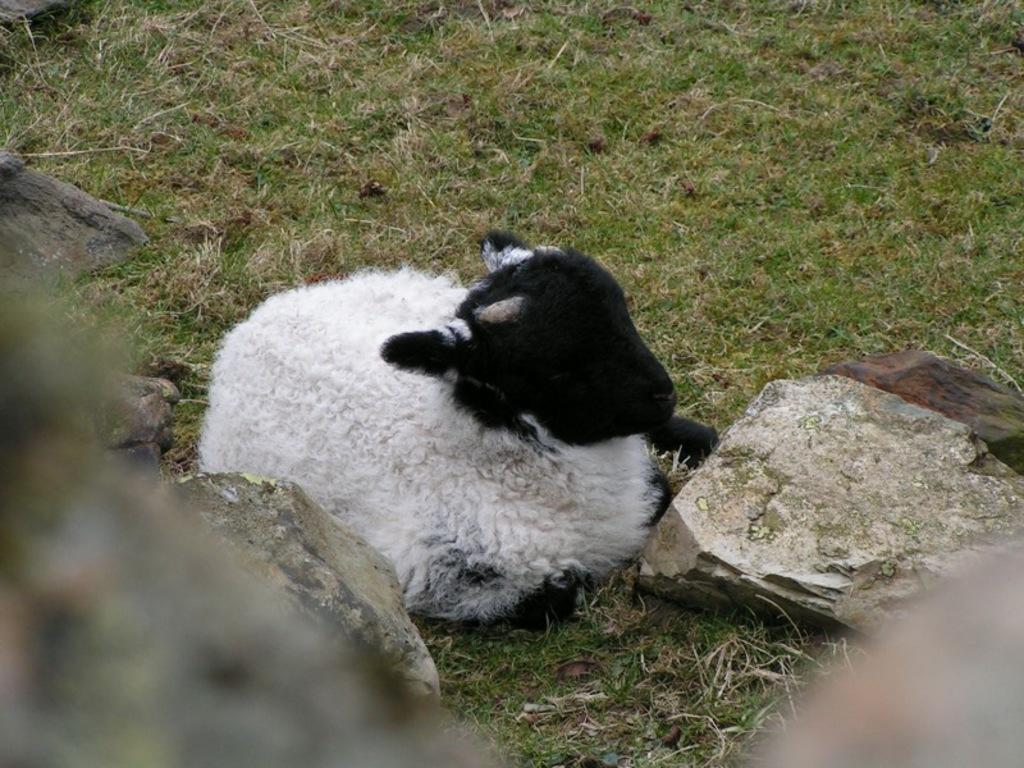What animal is present in the image? There is a sheep in the picture. What is the sheep doing in the image? The sheep is sitting on the grass. What type of vegetation can be seen in the image? There is grass visible in the image. What is located at the bottom of the image? There are stones at the bottom of the image. What type of tin can be seen hanging from the scarecrow in the image? There is no scarecrow or tin present in the image; it features a sheep sitting on the grass. How many bears are visible in the image? There are no bears present in the image. 